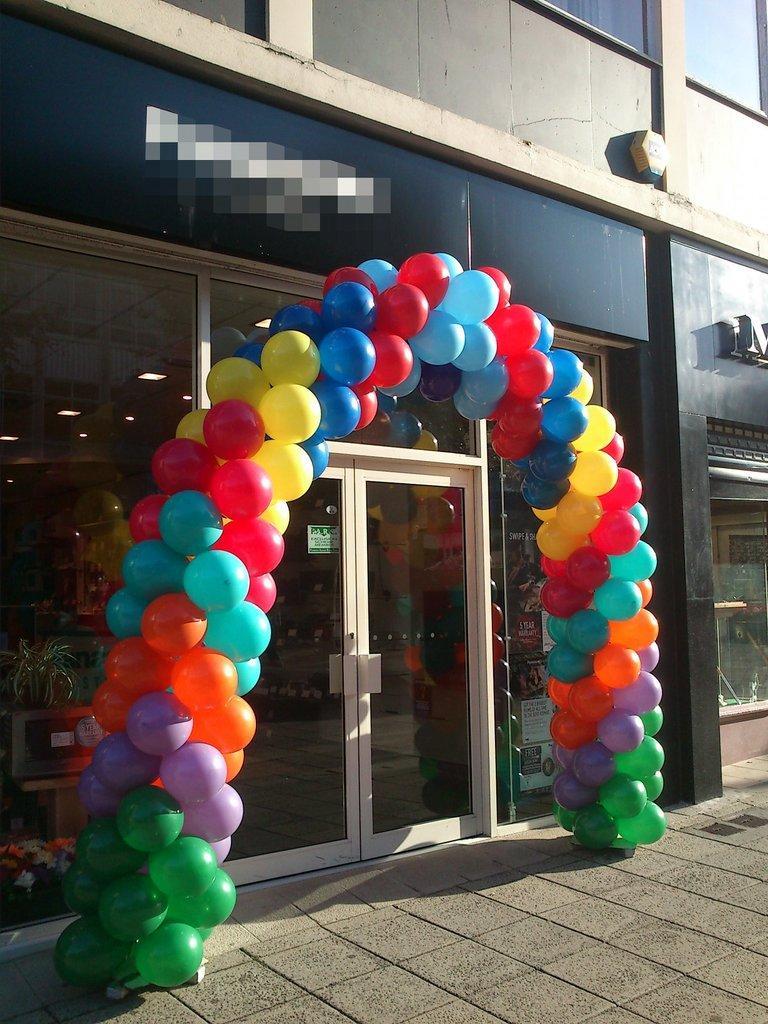Could you give a brief overview of what you see in this image? In the center of the image there is a building. There is a glass door. There is a balloon arch. At the bottom of the image there is floor. 